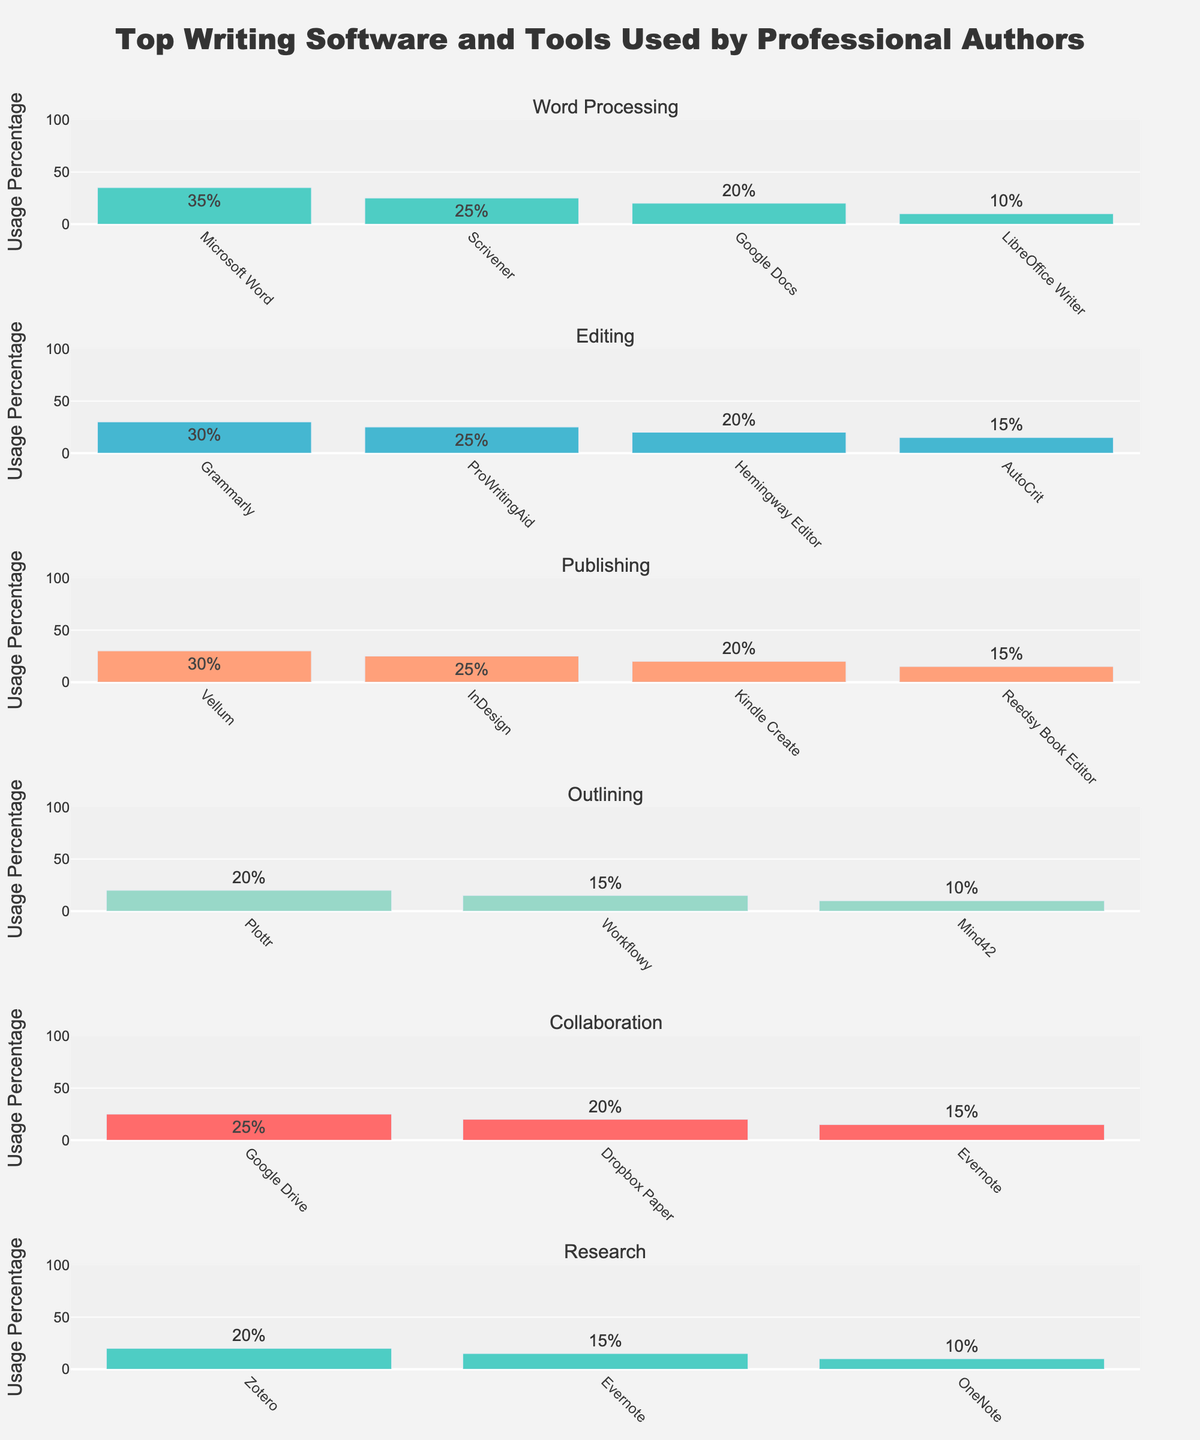Which word processing software is used the most by professional authors? The bar chart shows usage percentage for different word processing software. Microsoft Word has the highest bar in this category, indicating it is used the most.
Answer: Microsoft Word What is the total usage percentage of editing tools mentioned in the figure? To find the total usage percentage of editing tools, sum the usage percentages of Grammarly, ProWritingAid, Hemingway Editor, and AutoCrit. That's 30% + 25% + 20% + 15% = 90%.
Answer: 90% Which category has the tool with the highest usage percentage overall? By comparing the highest usage percentage in each category: Word Processing (Microsoft Word, 35%), Editing (Grammarly, 30%), Publishing (Vellum, 30%), Outlining (Plottr, 20%), Collaboration (Google Drive, 25%), and Research (Zotero, 20%). Microsoft Word in the Word Processing category has the highest at 35%.
Answer: Word Processing For the publishing tools, what is the difference in usage percentage between Vellum and Kindle Create? The usage percentage of Vellum is 30%, and Kindle Create is 20%. The difference is 30% - 20% = 10%.
Answer: 10% Is Google Docs used more for collaboration or word processing? Comparing the bars for Google Docs in both categories: it appears under Word Processing with 20% and does not appear in Collaboration. Therefore, it is only used in Word Processing.
Answer: Word Processing Which outlining tool is used the least by professional authors? By looking at the bars in the Outlining category, Mind42 has the lowest usage percentage at 10%.
Answer: Mind42 How does the usage of Grammarly compare to InDesign? Grammarly has a usage percentage of 30% in the Editing category, whereas InDesign has a usage percentage of 25% in the Publishing category. Grammarly's percentage is higher.
Answer: Grammarly What are the combined usage percentages of the top tools for word processing and editing? The top tools for word processing and editing are Microsoft Word (35%) and Grammarly (30%), respectively. Sum them to get 35% + 30% = 65%.
Answer: 65% Which category has the most evenly distributed usage percentages among its tools? By visually inspecting the bar heights, the Research category has tools with usage percentages of 20%, 15%, and 10%, which seem quite close to each other compared to other categories.
Answer: Research What is the average usage percentage of the tools in the Collaboration category? The Collaboration category has Google Drive (25%), Dropbox Paper (20%), and Evernote (15%). The average is (25% + 20% + 15%) / 3 = 20%.
Answer: 20% 